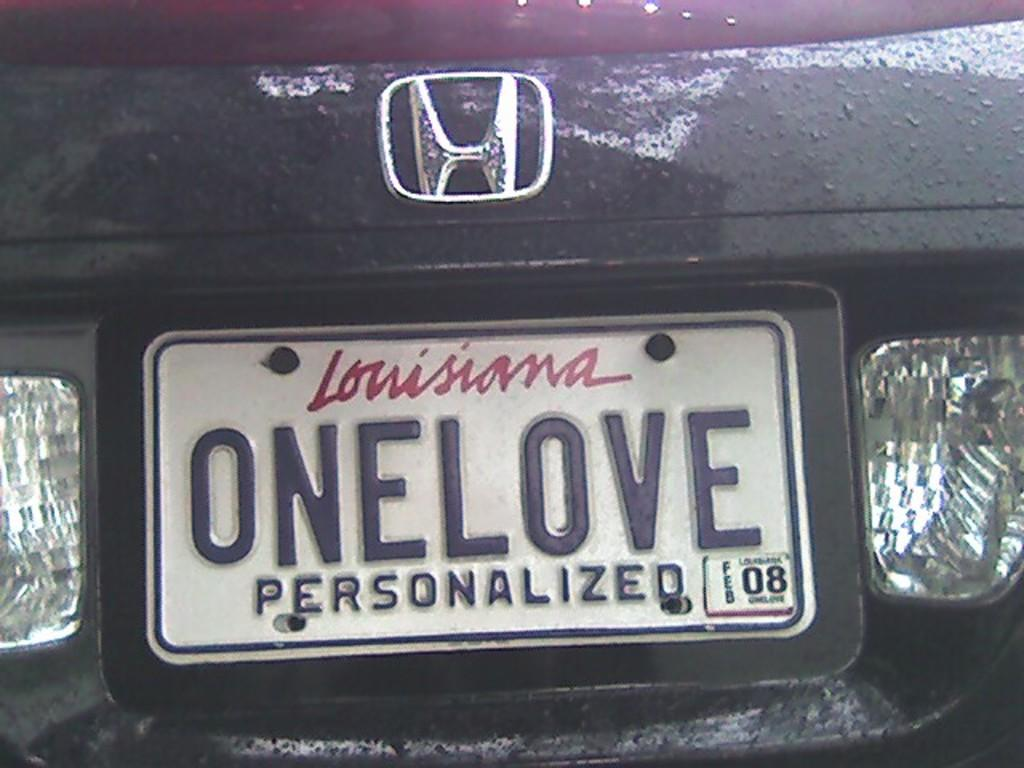What is present on the car that can help identify it? There is a number plate on the car. What information can be found on the number plate? The number plate has text on it. What features of the car are visible in the image? There are lights visible on the car. What type of art can be seen on the car's flesh in the image? There is no mention of art, flesh, or an animal in the image; it only features a car with a number plate and lights. 